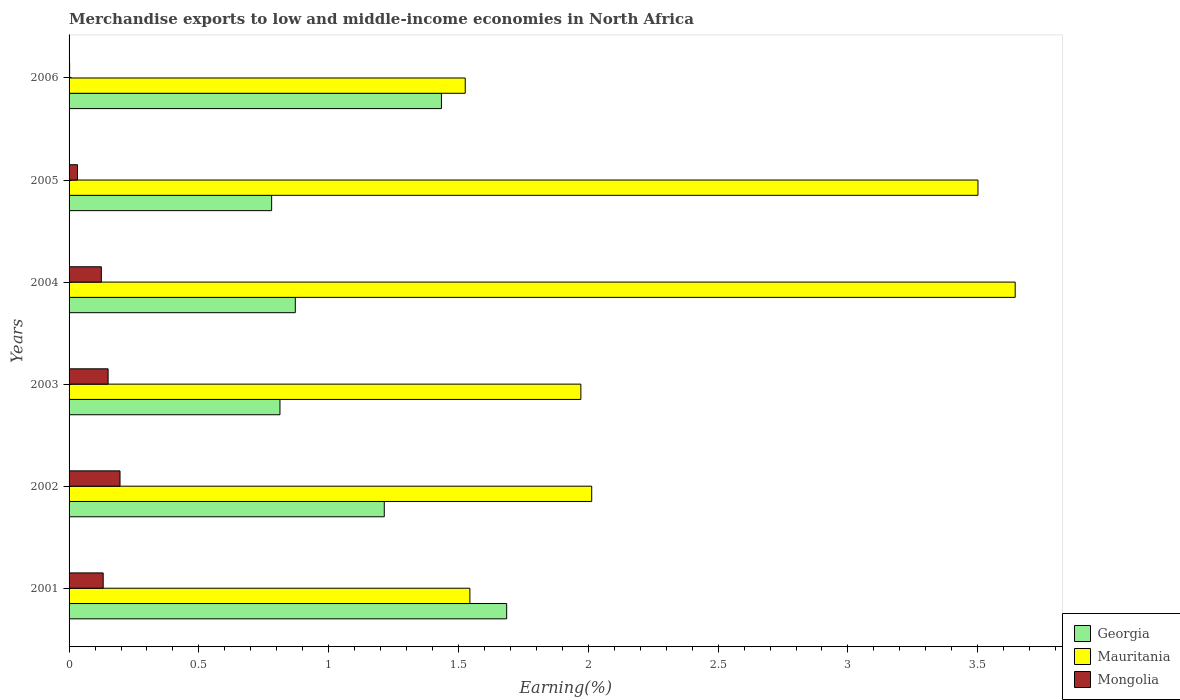How many groups of bars are there?
Give a very brief answer. 6. Are the number of bars on each tick of the Y-axis equal?
Offer a terse response. Yes. How many bars are there on the 1st tick from the bottom?
Your answer should be very brief. 3. What is the label of the 1st group of bars from the top?
Give a very brief answer. 2006. In how many cases, is the number of bars for a given year not equal to the number of legend labels?
Provide a short and direct response. 0. What is the percentage of amount earned from merchandise exports in Mauritania in 2005?
Offer a terse response. 3.5. Across all years, what is the maximum percentage of amount earned from merchandise exports in Mongolia?
Provide a short and direct response. 0.2. Across all years, what is the minimum percentage of amount earned from merchandise exports in Georgia?
Your response must be concise. 0.78. In which year was the percentage of amount earned from merchandise exports in Georgia minimum?
Ensure brevity in your answer.  2005. What is the total percentage of amount earned from merchandise exports in Georgia in the graph?
Give a very brief answer. 6.8. What is the difference between the percentage of amount earned from merchandise exports in Mauritania in 2004 and that in 2006?
Keep it short and to the point. 2.12. What is the difference between the percentage of amount earned from merchandise exports in Georgia in 2001 and the percentage of amount earned from merchandise exports in Mauritania in 2003?
Keep it short and to the point. -0.29. What is the average percentage of amount earned from merchandise exports in Mauritania per year?
Make the answer very short. 2.37. In the year 2001, what is the difference between the percentage of amount earned from merchandise exports in Mongolia and percentage of amount earned from merchandise exports in Mauritania?
Your answer should be compact. -1.41. In how many years, is the percentage of amount earned from merchandise exports in Mongolia greater than 1.2 %?
Make the answer very short. 0. What is the ratio of the percentage of amount earned from merchandise exports in Georgia in 2003 to that in 2006?
Your response must be concise. 0.57. Is the percentage of amount earned from merchandise exports in Mongolia in 2001 less than that in 2002?
Keep it short and to the point. Yes. What is the difference between the highest and the second highest percentage of amount earned from merchandise exports in Georgia?
Your response must be concise. 0.25. What is the difference between the highest and the lowest percentage of amount earned from merchandise exports in Mauritania?
Make the answer very short. 2.12. In how many years, is the percentage of amount earned from merchandise exports in Mauritania greater than the average percentage of amount earned from merchandise exports in Mauritania taken over all years?
Your response must be concise. 2. What does the 3rd bar from the top in 2003 represents?
Offer a very short reply. Georgia. What does the 3rd bar from the bottom in 2005 represents?
Keep it short and to the point. Mongolia. Are all the bars in the graph horizontal?
Your answer should be very brief. Yes. What is the difference between two consecutive major ticks on the X-axis?
Provide a succinct answer. 0.5. Are the values on the major ticks of X-axis written in scientific E-notation?
Provide a succinct answer. No. Does the graph contain any zero values?
Offer a very short reply. No. Does the graph contain grids?
Provide a short and direct response. No. Where does the legend appear in the graph?
Your answer should be very brief. Bottom right. How many legend labels are there?
Provide a succinct answer. 3. How are the legend labels stacked?
Your answer should be very brief. Vertical. What is the title of the graph?
Offer a terse response. Merchandise exports to low and middle-income economies in North Africa. What is the label or title of the X-axis?
Give a very brief answer. Earning(%). What is the label or title of the Y-axis?
Offer a terse response. Years. What is the Earning(%) of Georgia in 2001?
Your response must be concise. 1.69. What is the Earning(%) of Mauritania in 2001?
Offer a very short reply. 1.54. What is the Earning(%) of Mongolia in 2001?
Your answer should be very brief. 0.13. What is the Earning(%) of Georgia in 2002?
Offer a very short reply. 1.21. What is the Earning(%) of Mauritania in 2002?
Your answer should be compact. 2.01. What is the Earning(%) of Mongolia in 2002?
Offer a very short reply. 0.2. What is the Earning(%) of Georgia in 2003?
Your answer should be compact. 0.81. What is the Earning(%) in Mauritania in 2003?
Make the answer very short. 1.97. What is the Earning(%) in Mongolia in 2003?
Your response must be concise. 0.15. What is the Earning(%) in Georgia in 2004?
Your answer should be compact. 0.87. What is the Earning(%) in Mauritania in 2004?
Provide a short and direct response. 3.64. What is the Earning(%) of Mongolia in 2004?
Ensure brevity in your answer.  0.12. What is the Earning(%) in Georgia in 2005?
Provide a short and direct response. 0.78. What is the Earning(%) of Mauritania in 2005?
Offer a terse response. 3.5. What is the Earning(%) in Mongolia in 2005?
Offer a very short reply. 0.03. What is the Earning(%) of Georgia in 2006?
Your response must be concise. 1.43. What is the Earning(%) of Mauritania in 2006?
Your response must be concise. 1.53. What is the Earning(%) of Mongolia in 2006?
Offer a terse response. 0. Across all years, what is the maximum Earning(%) in Georgia?
Your response must be concise. 1.69. Across all years, what is the maximum Earning(%) in Mauritania?
Your answer should be very brief. 3.64. Across all years, what is the maximum Earning(%) in Mongolia?
Ensure brevity in your answer.  0.2. Across all years, what is the minimum Earning(%) in Georgia?
Keep it short and to the point. 0.78. Across all years, what is the minimum Earning(%) of Mauritania?
Your response must be concise. 1.53. Across all years, what is the minimum Earning(%) of Mongolia?
Keep it short and to the point. 0. What is the total Earning(%) of Georgia in the graph?
Your answer should be very brief. 6.8. What is the total Earning(%) in Mauritania in the graph?
Offer a very short reply. 14.2. What is the total Earning(%) in Mongolia in the graph?
Provide a short and direct response. 0.64. What is the difference between the Earning(%) in Georgia in 2001 and that in 2002?
Offer a very short reply. 0.47. What is the difference between the Earning(%) of Mauritania in 2001 and that in 2002?
Ensure brevity in your answer.  -0.47. What is the difference between the Earning(%) in Mongolia in 2001 and that in 2002?
Keep it short and to the point. -0.06. What is the difference between the Earning(%) in Georgia in 2001 and that in 2003?
Keep it short and to the point. 0.87. What is the difference between the Earning(%) of Mauritania in 2001 and that in 2003?
Your answer should be very brief. -0.43. What is the difference between the Earning(%) of Mongolia in 2001 and that in 2003?
Offer a very short reply. -0.02. What is the difference between the Earning(%) of Georgia in 2001 and that in 2004?
Keep it short and to the point. 0.81. What is the difference between the Earning(%) of Mauritania in 2001 and that in 2004?
Provide a short and direct response. -2.1. What is the difference between the Earning(%) of Mongolia in 2001 and that in 2004?
Give a very brief answer. 0.01. What is the difference between the Earning(%) in Georgia in 2001 and that in 2005?
Ensure brevity in your answer.  0.91. What is the difference between the Earning(%) in Mauritania in 2001 and that in 2005?
Ensure brevity in your answer.  -1.96. What is the difference between the Earning(%) in Mongolia in 2001 and that in 2005?
Give a very brief answer. 0.1. What is the difference between the Earning(%) in Georgia in 2001 and that in 2006?
Your response must be concise. 0.25. What is the difference between the Earning(%) of Mauritania in 2001 and that in 2006?
Make the answer very short. 0.02. What is the difference between the Earning(%) in Mongolia in 2001 and that in 2006?
Make the answer very short. 0.13. What is the difference between the Earning(%) of Georgia in 2002 and that in 2003?
Your response must be concise. 0.4. What is the difference between the Earning(%) in Mauritania in 2002 and that in 2003?
Ensure brevity in your answer.  0.04. What is the difference between the Earning(%) of Mongolia in 2002 and that in 2003?
Give a very brief answer. 0.05. What is the difference between the Earning(%) of Georgia in 2002 and that in 2004?
Keep it short and to the point. 0.34. What is the difference between the Earning(%) of Mauritania in 2002 and that in 2004?
Your answer should be compact. -1.63. What is the difference between the Earning(%) of Mongolia in 2002 and that in 2004?
Your answer should be very brief. 0.07. What is the difference between the Earning(%) in Georgia in 2002 and that in 2005?
Make the answer very short. 0.43. What is the difference between the Earning(%) in Mauritania in 2002 and that in 2005?
Your answer should be compact. -1.49. What is the difference between the Earning(%) of Mongolia in 2002 and that in 2005?
Give a very brief answer. 0.16. What is the difference between the Earning(%) of Georgia in 2002 and that in 2006?
Your response must be concise. -0.22. What is the difference between the Earning(%) of Mauritania in 2002 and that in 2006?
Ensure brevity in your answer.  0.49. What is the difference between the Earning(%) in Mongolia in 2002 and that in 2006?
Offer a very short reply. 0.19. What is the difference between the Earning(%) of Georgia in 2003 and that in 2004?
Make the answer very short. -0.06. What is the difference between the Earning(%) of Mauritania in 2003 and that in 2004?
Offer a very short reply. -1.67. What is the difference between the Earning(%) in Mongolia in 2003 and that in 2004?
Offer a very short reply. 0.03. What is the difference between the Earning(%) in Georgia in 2003 and that in 2005?
Keep it short and to the point. 0.03. What is the difference between the Earning(%) in Mauritania in 2003 and that in 2005?
Offer a very short reply. -1.53. What is the difference between the Earning(%) in Mongolia in 2003 and that in 2005?
Offer a very short reply. 0.12. What is the difference between the Earning(%) in Georgia in 2003 and that in 2006?
Your response must be concise. -0.62. What is the difference between the Earning(%) in Mauritania in 2003 and that in 2006?
Offer a very short reply. 0.45. What is the difference between the Earning(%) of Mongolia in 2003 and that in 2006?
Give a very brief answer. 0.15. What is the difference between the Earning(%) of Georgia in 2004 and that in 2005?
Give a very brief answer. 0.09. What is the difference between the Earning(%) of Mauritania in 2004 and that in 2005?
Your answer should be very brief. 0.14. What is the difference between the Earning(%) of Mongolia in 2004 and that in 2005?
Offer a very short reply. 0.09. What is the difference between the Earning(%) of Georgia in 2004 and that in 2006?
Give a very brief answer. -0.56. What is the difference between the Earning(%) of Mauritania in 2004 and that in 2006?
Your answer should be very brief. 2.12. What is the difference between the Earning(%) of Mongolia in 2004 and that in 2006?
Provide a succinct answer. 0.12. What is the difference between the Earning(%) of Georgia in 2005 and that in 2006?
Your answer should be very brief. -0.65. What is the difference between the Earning(%) in Mauritania in 2005 and that in 2006?
Provide a short and direct response. 1.97. What is the difference between the Earning(%) in Mongolia in 2005 and that in 2006?
Your response must be concise. 0.03. What is the difference between the Earning(%) in Georgia in 2001 and the Earning(%) in Mauritania in 2002?
Your response must be concise. -0.33. What is the difference between the Earning(%) in Georgia in 2001 and the Earning(%) in Mongolia in 2002?
Give a very brief answer. 1.49. What is the difference between the Earning(%) of Mauritania in 2001 and the Earning(%) of Mongolia in 2002?
Provide a succinct answer. 1.35. What is the difference between the Earning(%) in Georgia in 2001 and the Earning(%) in Mauritania in 2003?
Make the answer very short. -0.29. What is the difference between the Earning(%) of Georgia in 2001 and the Earning(%) of Mongolia in 2003?
Keep it short and to the point. 1.54. What is the difference between the Earning(%) of Mauritania in 2001 and the Earning(%) of Mongolia in 2003?
Offer a terse response. 1.39. What is the difference between the Earning(%) of Georgia in 2001 and the Earning(%) of Mauritania in 2004?
Offer a terse response. -1.96. What is the difference between the Earning(%) of Georgia in 2001 and the Earning(%) of Mongolia in 2004?
Your answer should be compact. 1.56. What is the difference between the Earning(%) of Mauritania in 2001 and the Earning(%) of Mongolia in 2004?
Your response must be concise. 1.42. What is the difference between the Earning(%) of Georgia in 2001 and the Earning(%) of Mauritania in 2005?
Your answer should be compact. -1.82. What is the difference between the Earning(%) of Georgia in 2001 and the Earning(%) of Mongolia in 2005?
Your response must be concise. 1.65. What is the difference between the Earning(%) of Mauritania in 2001 and the Earning(%) of Mongolia in 2005?
Your response must be concise. 1.51. What is the difference between the Earning(%) in Georgia in 2001 and the Earning(%) in Mauritania in 2006?
Keep it short and to the point. 0.16. What is the difference between the Earning(%) in Georgia in 2001 and the Earning(%) in Mongolia in 2006?
Ensure brevity in your answer.  1.68. What is the difference between the Earning(%) of Mauritania in 2001 and the Earning(%) of Mongolia in 2006?
Give a very brief answer. 1.54. What is the difference between the Earning(%) in Georgia in 2002 and the Earning(%) in Mauritania in 2003?
Make the answer very short. -0.76. What is the difference between the Earning(%) in Georgia in 2002 and the Earning(%) in Mongolia in 2003?
Offer a very short reply. 1.06. What is the difference between the Earning(%) of Mauritania in 2002 and the Earning(%) of Mongolia in 2003?
Your answer should be compact. 1.86. What is the difference between the Earning(%) of Georgia in 2002 and the Earning(%) of Mauritania in 2004?
Offer a very short reply. -2.43. What is the difference between the Earning(%) in Georgia in 2002 and the Earning(%) in Mongolia in 2004?
Your answer should be compact. 1.09. What is the difference between the Earning(%) of Mauritania in 2002 and the Earning(%) of Mongolia in 2004?
Provide a succinct answer. 1.89. What is the difference between the Earning(%) of Georgia in 2002 and the Earning(%) of Mauritania in 2005?
Make the answer very short. -2.29. What is the difference between the Earning(%) of Georgia in 2002 and the Earning(%) of Mongolia in 2005?
Your answer should be compact. 1.18. What is the difference between the Earning(%) in Mauritania in 2002 and the Earning(%) in Mongolia in 2005?
Keep it short and to the point. 1.98. What is the difference between the Earning(%) in Georgia in 2002 and the Earning(%) in Mauritania in 2006?
Keep it short and to the point. -0.31. What is the difference between the Earning(%) of Georgia in 2002 and the Earning(%) of Mongolia in 2006?
Give a very brief answer. 1.21. What is the difference between the Earning(%) in Mauritania in 2002 and the Earning(%) in Mongolia in 2006?
Offer a terse response. 2.01. What is the difference between the Earning(%) of Georgia in 2003 and the Earning(%) of Mauritania in 2004?
Ensure brevity in your answer.  -2.83. What is the difference between the Earning(%) of Georgia in 2003 and the Earning(%) of Mongolia in 2004?
Ensure brevity in your answer.  0.69. What is the difference between the Earning(%) in Mauritania in 2003 and the Earning(%) in Mongolia in 2004?
Make the answer very short. 1.85. What is the difference between the Earning(%) in Georgia in 2003 and the Earning(%) in Mauritania in 2005?
Provide a short and direct response. -2.69. What is the difference between the Earning(%) of Georgia in 2003 and the Earning(%) of Mongolia in 2005?
Offer a terse response. 0.78. What is the difference between the Earning(%) of Mauritania in 2003 and the Earning(%) of Mongolia in 2005?
Your answer should be compact. 1.94. What is the difference between the Earning(%) in Georgia in 2003 and the Earning(%) in Mauritania in 2006?
Keep it short and to the point. -0.71. What is the difference between the Earning(%) in Georgia in 2003 and the Earning(%) in Mongolia in 2006?
Provide a short and direct response. 0.81. What is the difference between the Earning(%) of Mauritania in 2003 and the Earning(%) of Mongolia in 2006?
Keep it short and to the point. 1.97. What is the difference between the Earning(%) of Georgia in 2004 and the Earning(%) of Mauritania in 2005?
Ensure brevity in your answer.  -2.63. What is the difference between the Earning(%) of Georgia in 2004 and the Earning(%) of Mongolia in 2005?
Give a very brief answer. 0.84. What is the difference between the Earning(%) of Mauritania in 2004 and the Earning(%) of Mongolia in 2005?
Keep it short and to the point. 3.61. What is the difference between the Earning(%) in Georgia in 2004 and the Earning(%) in Mauritania in 2006?
Your answer should be compact. -0.65. What is the difference between the Earning(%) of Georgia in 2004 and the Earning(%) of Mongolia in 2006?
Your answer should be compact. 0.87. What is the difference between the Earning(%) of Mauritania in 2004 and the Earning(%) of Mongolia in 2006?
Give a very brief answer. 3.64. What is the difference between the Earning(%) of Georgia in 2005 and the Earning(%) of Mauritania in 2006?
Keep it short and to the point. -0.75. What is the difference between the Earning(%) in Georgia in 2005 and the Earning(%) in Mongolia in 2006?
Make the answer very short. 0.78. What is the difference between the Earning(%) in Mauritania in 2005 and the Earning(%) in Mongolia in 2006?
Give a very brief answer. 3.5. What is the average Earning(%) in Georgia per year?
Provide a short and direct response. 1.13. What is the average Earning(%) of Mauritania per year?
Make the answer very short. 2.37. What is the average Earning(%) in Mongolia per year?
Your answer should be very brief. 0.11. In the year 2001, what is the difference between the Earning(%) in Georgia and Earning(%) in Mauritania?
Your answer should be compact. 0.14. In the year 2001, what is the difference between the Earning(%) of Georgia and Earning(%) of Mongolia?
Offer a terse response. 1.55. In the year 2001, what is the difference between the Earning(%) in Mauritania and Earning(%) in Mongolia?
Make the answer very short. 1.41. In the year 2002, what is the difference between the Earning(%) in Georgia and Earning(%) in Mauritania?
Offer a terse response. -0.8. In the year 2002, what is the difference between the Earning(%) in Georgia and Earning(%) in Mongolia?
Offer a terse response. 1.02. In the year 2002, what is the difference between the Earning(%) of Mauritania and Earning(%) of Mongolia?
Provide a succinct answer. 1.82. In the year 2003, what is the difference between the Earning(%) of Georgia and Earning(%) of Mauritania?
Offer a terse response. -1.16. In the year 2003, what is the difference between the Earning(%) of Georgia and Earning(%) of Mongolia?
Give a very brief answer. 0.66. In the year 2003, what is the difference between the Earning(%) in Mauritania and Earning(%) in Mongolia?
Provide a short and direct response. 1.82. In the year 2004, what is the difference between the Earning(%) of Georgia and Earning(%) of Mauritania?
Offer a very short reply. -2.77. In the year 2004, what is the difference between the Earning(%) in Georgia and Earning(%) in Mongolia?
Make the answer very short. 0.75. In the year 2004, what is the difference between the Earning(%) in Mauritania and Earning(%) in Mongolia?
Your answer should be very brief. 3.52. In the year 2005, what is the difference between the Earning(%) of Georgia and Earning(%) of Mauritania?
Provide a short and direct response. -2.72. In the year 2005, what is the difference between the Earning(%) of Georgia and Earning(%) of Mongolia?
Give a very brief answer. 0.75. In the year 2005, what is the difference between the Earning(%) in Mauritania and Earning(%) in Mongolia?
Provide a short and direct response. 3.47. In the year 2006, what is the difference between the Earning(%) in Georgia and Earning(%) in Mauritania?
Your response must be concise. -0.09. In the year 2006, what is the difference between the Earning(%) in Georgia and Earning(%) in Mongolia?
Offer a very short reply. 1.43. In the year 2006, what is the difference between the Earning(%) in Mauritania and Earning(%) in Mongolia?
Offer a very short reply. 1.52. What is the ratio of the Earning(%) of Georgia in 2001 to that in 2002?
Offer a terse response. 1.39. What is the ratio of the Earning(%) of Mauritania in 2001 to that in 2002?
Your response must be concise. 0.77. What is the ratio of the Earning(%) in Mongolia in 2001 to that in 2002?
Give a very brief answer. 0.67. What is the ratio of the Earning(%) of Georgia in 2001 to that in 2003?
Make the answer very short. 2.07. What is the ratio of the Earning(%) in Mauritania in 2001 to that in 2003?
Your answer should be compact. 0.78. What is the ratio of the Earning(%) of Mongolia in 2001 to that in 2003?
Your answer should be compact. 0.87. What is the ratio of the Earning(%) of Georgia in 2001 to that in 2004?
Offer a terse response. 1.93. What is the ratio of the Earning(%) in Mauritania in 2001 to that in 2004?
Give a very brief answer. 0.42. What is the ratio of the Earning(%) of Mongolia in 2001 to that in 2004?
Offer a terse response. 1.06. What is the ratio of the Earning(%) in Georgia in 2001 to that in 2005?
Give a very brief answer. 2.16. What is the ratio of the Earning(%) of Mauritania in 2001 to that in 2005?
Give a very brief answer. 0.44. What is the ratio of the Earning(%) in Mongolia in 2001 to that in 2005?
Give a very brief answer. 4.06. What is the ratio of the Earning(%) of Georgia in 2001 to that in 2006?
Keep it short and to the point. 1.18. What is the ratio of the Earning(%) in Mauritania in 2001 to that in 2006?
Provide a succinct answer. 1.01. What is the ratio of the Earning(%) of Mongolia in 2001 to that in 2006?
Your answer should be very brief. 64.11. What is the ratio of the Earning(%) in Georgia in 2002 to that in 2003?
Offer a terse response. 1.49. What is the ratio of the Earning(%) of Mauritania in 2002 to that in 2003?
Ensure brevity in your answer.  1.02. What is the ratio of the Earning(%) in Mongolia in 2002 to that in 2003?
Offer a terse response. 1.3. What is the ratio of the Earning(%) in Georgia in 2002 to that in 2004?
Your answer should be compact. 1.39. What is the ratio of the Earning(%) in Mauritania in 2002 to that in 2004?
Provide a succinct answer. 0.55. What is the ratio of the Earning(%) of Mongolia in 2002 to that in 2004?
Offer a very short reply. 1.58. What is the ratio of the Earning(%) of Georgia in 2002 to that in 2005?
Provide a succinct answer. 1.56. What is the ratio of the Earning(%) in Mauritania in 2002 to that in 2005?
Provide a short and direct response. 0.57. What is the ratio of the Earning(%) in Mongolia in 2002 to that in 2005?
Ensure brevity in your answer.  6.06. What is the ratio of the Earning(%) in Georgia in 2002 to that in 2006?
Give a very brief answer. 0.85. What is the ratio of the Earning(%) of Mauritania in 2002 to that in 2006?
Provide a succinct answer. 1.32. What is the ratio of the Earning(%) of Mongolia in 2002 to that in 2006?
Give a very brief answer. 95.76. What is the ratio of the Earning(%) of Georgia in 2003 to that in 2004?
Offer a terse response. 0.93. What is the ratio of the Earning(%) in Mauritania in 2003 to that in 2004?
Offer a terse response. 0.54. What is the ratio of the Earning(%) in Mongolia in 2003 to that in 2004?
Give a very brief answer. 1.21. What is the ratio of the Earning(%) in Georgia in 2003 to that in 2005?
Keep it short and to the point. 1.04. What is the ratio of the Earning(%) in Mauritania in 2003 to that in 2005?
Your answer should be very brief. 0.56. What is the ratio of the Earning(%) of Mongolia in 2003 to that in 2005?
Your response must be concise. 4.64. What is the ratio of the Earning(%) in Georgia in 2003 to that in 2006?
Ensure brevity in your answer.  0.57. What is the ratio of the Earning(%) of Mauritania in 2003 to that in 2006?
Make the answer very short. 1.29. What is the ratio of the Earning(%) in Mongolia in 2003 to that in 2006?
Your answer should be very brief. 73.38. What is the ratio of the Earning(%) in Georgia in 2004 to that in 2005?
Your response must be concise. 1.12. What is the ratio of the Earning(%) in Mauritania in 2004 to that in 2005?
Keep it short and to the point. 1.04. What is the ratio of the Earning(%) in Mongolia in 2004 to that in 2005?
Keep it short and to the point. 3.84. What is the ratio of the Earning(%) of Georgia in 2004 to that in 2006?
Offer a terse response. 0.61. What is the ratio of the Earning(%) in Mauritania in 2004 to that in 2006?
Make the answer very short. 2.39. What is the ratio of the Earning(%) in Mongolia in 2004 to that in 2006?
Offer a very short reply. 60.66. What is the ratio of the Earning(%) of Georgia in 2005 to that in 2006?
Your answer should be compact. 0.54. What is the ratio of the Earning(%) of Mauritania in 2005 to that in 2006?
Your answer should be compact. 2.29. What is the ratio of the Earning(%) in Mongolia in 2005 to that in 2006?
Give a very brief answer. 15.81. What is the difference between the highest and the second highest Earning(%) in Georgia?
Offer a terse response. 0.25. What is the difference between the highest and the second highest Earning(%) of Mauritania?
Your answer should be very brief. 0.14. What is the difference between the highest and the second highest Earning(%) in Mongolia?
Give a very brief answer. 0.05. What is the difference between the highest and the lowest Earning(%) in Georgia?
Offer a very short reply. 0.91. What is the difference between the highest and the lowest Earning(%) in Mauritania?
Provide a succinct answer. 2.12. What is the difference between the highest and the lowest Earning(%) of Mongolia?
Keep it short and to the point. 0.19. 